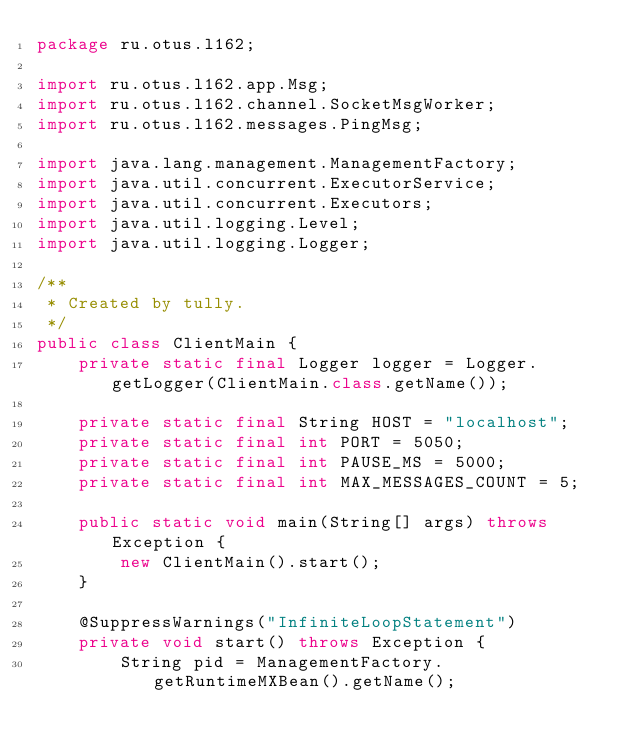Convert code to text. <code><loc_0><loc_0><loc_500><loc_500><_Java_>package ru.otus.l162;

import ru.otus.l162.app.Msg;
import ru.otus.l162.channel.SocketMsgWorker;
import ru.otus.l162.messages.PingMsg;

import java.lang.management.ManagementFactory;
import java.util.concurrent.ExecutorService;
import java.util.concurrent.Executors;
import java.util.logging.Level;
import java.util.logging.Logger;

/**
 * Created by tully.
 */
public class ClientMain {
    private static final Logger logger = Logger.getLogger(ClientMain.class.getName());

    private static final String HOST = "localhost";
    private static final int PORT = 5050;
    private static final int PAUSE_MS = 5000;
    private static final int MAX_MESSAGES_COUNT = 5;

    public static void main(String[] args) throws Exception {
        new ClientMain().start();
    }

    @SuppressWarnings("InfiniteLoopStatement")
    private void start() throws Exception {
        String pid = ManagementFactory.getRuntimeMXBean().getName();
</code> 